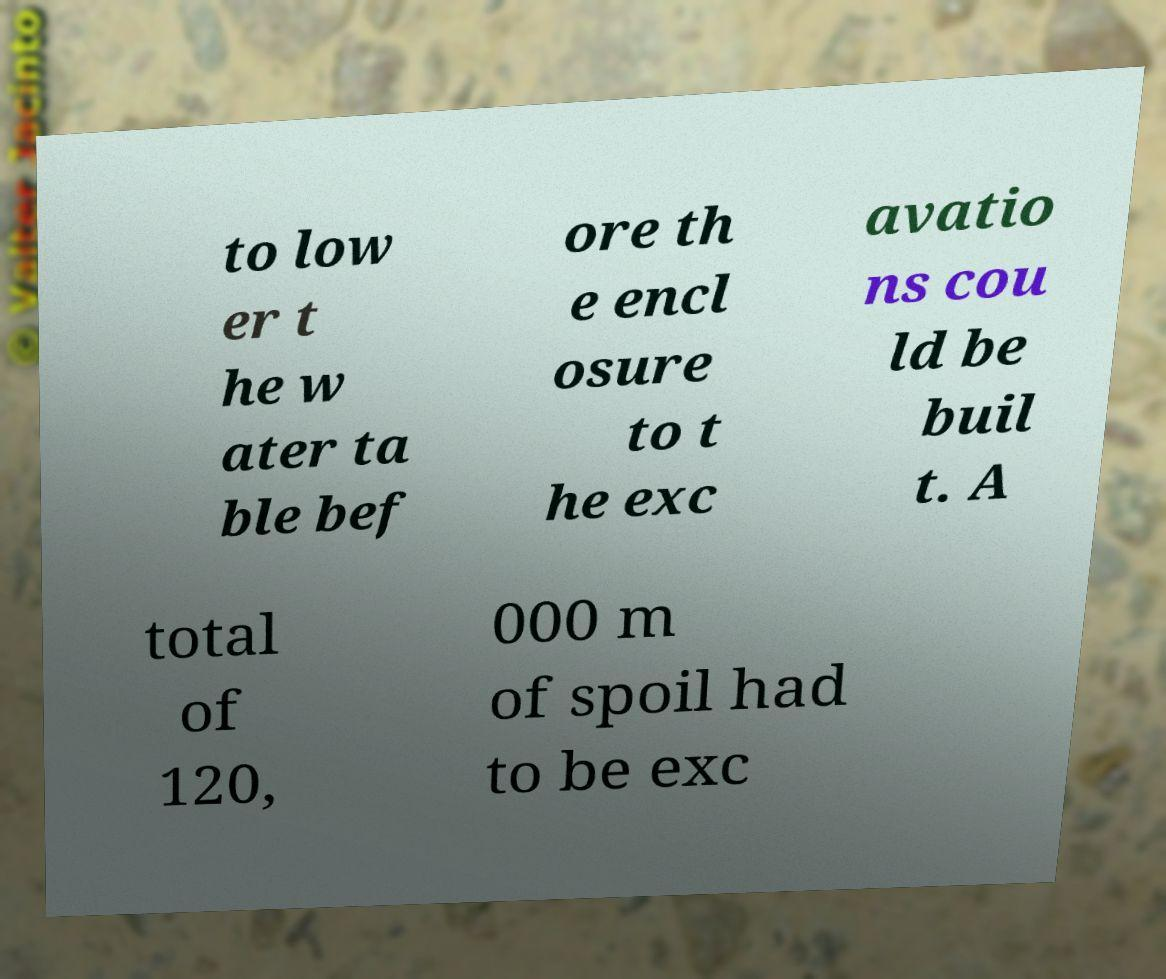Can you read and provide the text displayed in the image?This photo seems to have some interesting text. Can you extract and type it out for me? to low er t he w ater ta ble bef ore th e encl osure to t he exc avatio ns cou ld be buil t. A total of 120, 000 m of spoil had to be exc 